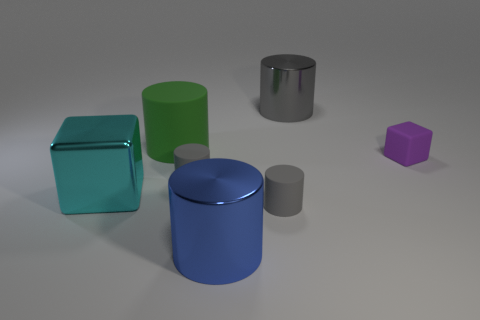Subtract all tiny gray rubber cylinders. How many cylinders are left? 3 Subtract all gray spheres. How many gray cylinders are left? 3 Subtract all green cylinders. How many cylinders are left? 4 Add 2 small gray objects. How many objects exist? 9 Subtract all cylinders. How many objects are left? 2 Add 3 blue shiny cylinders. How many blue shiny cylinders are left? 4 Add 4 big cyan cylinders. How many big cyan cylinders exist? 4 Subtract 0 red blocks. How many objects are left? 7 Subtract all purple cubes. Subtract all red cylinders. How many cubes are left? 1 Subtract all purple shiny objects. Subtract all tiny purple rubber things. How many objects are left? 6 